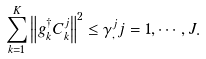<formula> <loc_0><loc_0><loc_500><loc_500>\sum _ { k = 1 } ^ { K } \left \| g _ { k } ^ { \dagger } { C ^ { j } _ { k } } \right \| ^ { 2 } \leq \gamma ^ { j } _ { , } j = 1 , \cdots , J .</formula> 